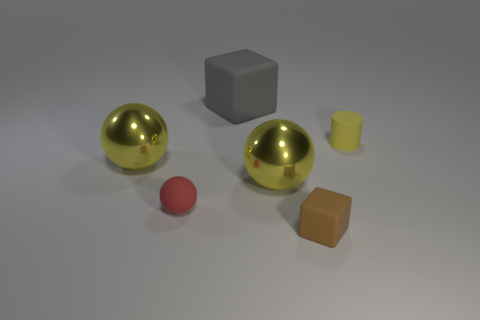Add 4 big things. How many objects exist? 10 Subtract all blocks. How many objects are left? 4 Add 6 purple matte cylinders. How many purple matte cylinders exist? 6 Subtract 0 cyan blocks. How many objects are left? 6 Subtract all blocks. Subtract all tiny rubber blocks. How many objects are left? 3 Add 3 tiny rubber objects. How many tiny rubber objects are left? 6 